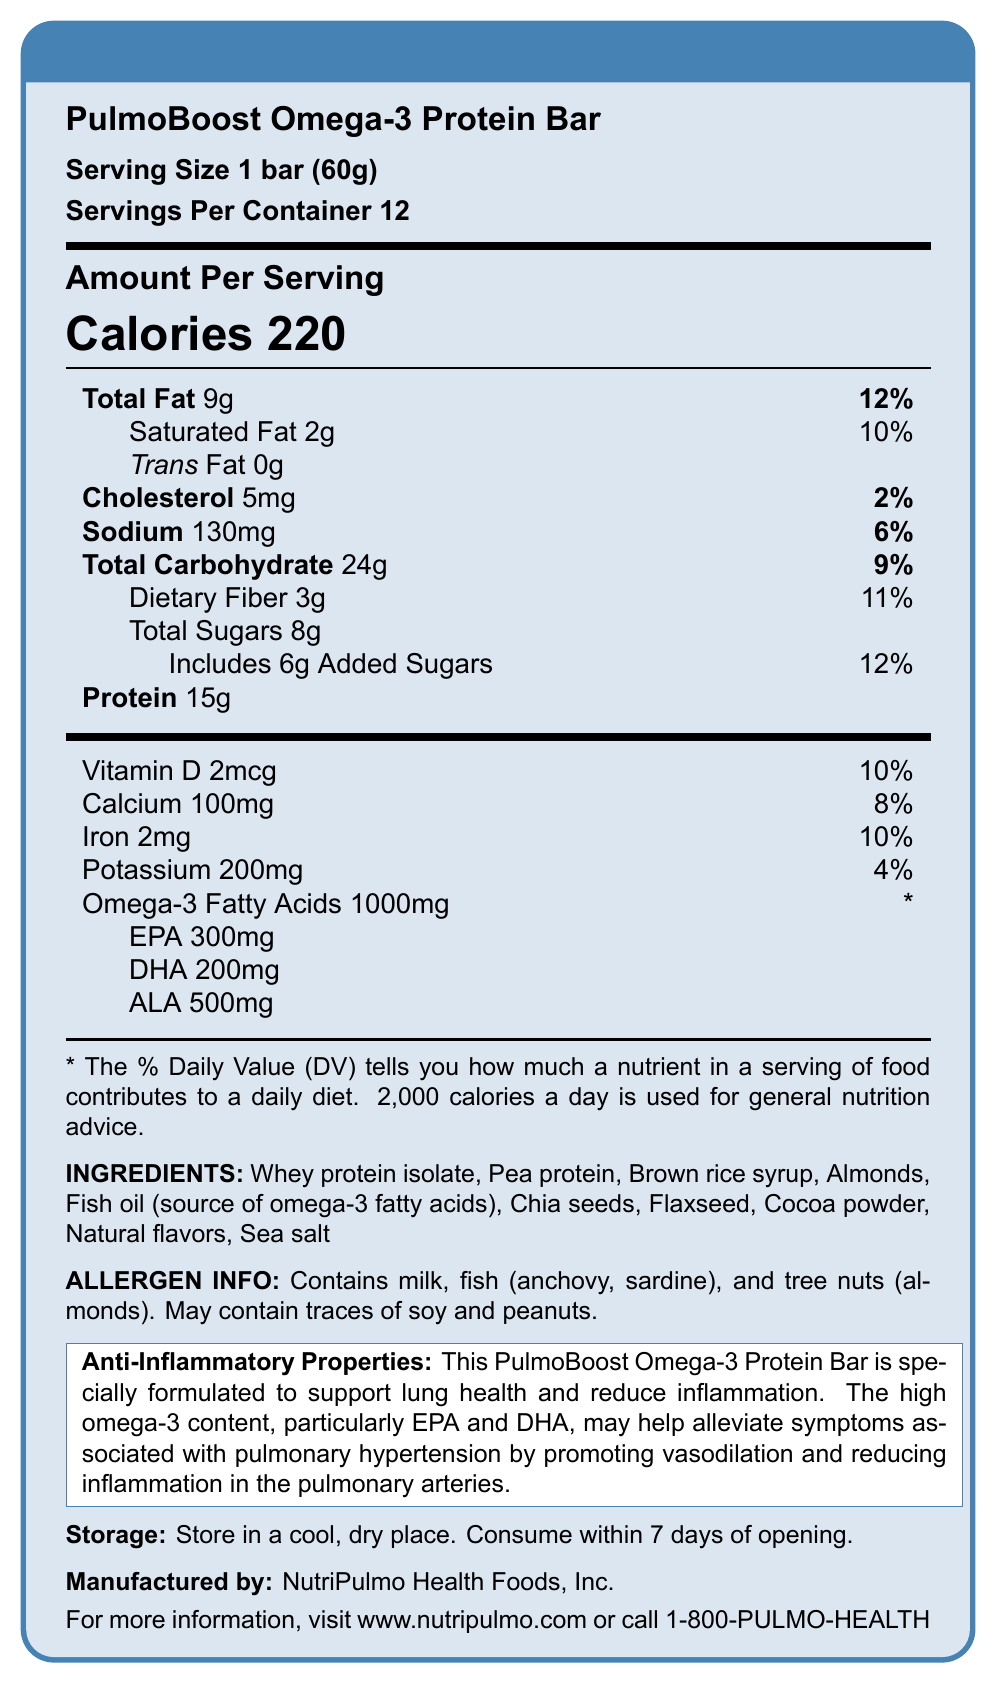What is the serving size of the PulmoBoost Omega-3 Protein Bar? The serving size is explicitly mentioned as "1 bar (60g)" in the nutrition facts section of the document.
Answer: 1 bar (60g) How many calories are there per serving? The document clearly states that each serving of the protein bar contains 220 calories.
Answer: 220 What is the amount of total fat in one serving? The total fat content per serving is listed as 9g in the nutrition facts.
Answer: 9g Which ingredient is a source of omega-3 fatty acids in the PulmoBoost Omega-3 Protein Bar? The ingredients list includes "Fish oil (source of omega-3 fatty acids)" which is identified as the source.
Answer: Fish oil What is the purpose of the high omega-3 content in this protein bar? There is a specific anti-inflammatory statement that mentions the high omega-3 content is designed to support lung health and reduce inflammation.
Answer: To support lung health and reduce inflammation How many bars are there per container? A. 6 B. 12 C. 24 The document mentions that there are 12 servings per container.
Answer: B. 12 Which of the following nutrients has the highest daily value percentage? A. Sodium B. Dietary Fiber C. Saturated Fat Saturated fat has a daily value percentage of 10%, which is higher compared to sodium (6%) and dietary fiber (11%).
Answer: C. Saturated Fat Does the PulmoBoost Omega-3 Protein Bar contain any added sugars? Yes/No The nutrition facts indicate that the bar includes 6g of added sugars.
Answer: Yes Summarize the main idea of the document. The document provides detailed nutritional information about the PulmoBoost Omega-3 Protein Bar, including its serving size, ingredient list, allergen information, and health benefits, particularly focusing on its anti-inflammatory properties for lung health.
Answer: PulmoBoost Omega-3 Protein Bar is designed to support lung health and reduce inflammation, especially for those with pulmonary hypertension. It contains 220 calories per serving, is fortified with omega-3 fatty acids (EPA, DHA, ALA), and provides various other nutrients. Who is the manufacturer of the PulmoBoost Omega-3 Protein Bar? The manufacturer is mentioned at the end of the nutrition facts box as NutriPulmo Health Foods, Inc.
Answer: NutriPulmo Health Foods, Inc. What is the source of dietary fiber in the PulmoBoost Omega-3 Protein Bar? The document lists the dietary fiber content but does not specify the individual sources of dietary fiber.
Answer: Cannot be determined What is the storage recommendation for the PulmoBoost Omega-3 Protein Bar? The document specifies storage instructions under the "Storage" section.
Answer: Store in a cool, dry place; consume within 7 days of opening How many milligrams of potassium are there in one serving? The nutrition facts list potassium content as 200mg per serving.
Answer: 200mg Which allergens are present in the PulmoBoost Omega-3 Protein Bar? Select all that apply. A. Milk B. Fish C. Wheat D. Tree nuts The allergen information section lists milk, fish (anchovy, sardine), and tree nuts (almonds).
Answer: A. Milk, B. Fish, D. Tree nuts What is the daily value percentage for vitamin D? The nutrition facts indicate that the vitamin D content provides 10% of the daily value.
Answer: 10% Is there any trans fat in the PulmoBoost Omega-3 Protein Bar? The nutrition facts explicitly state that there is 0g of trans fat.
Answer: No 